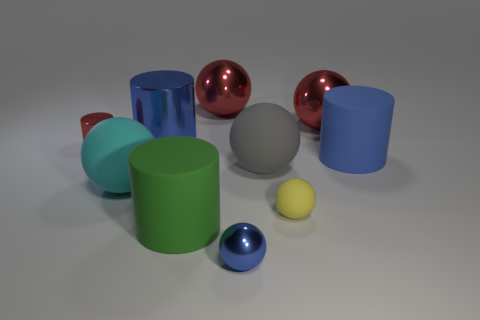How many objects in the image have a glossy surface? There are three objects with a glossy surface in the image: two spheres and one cylinder. 